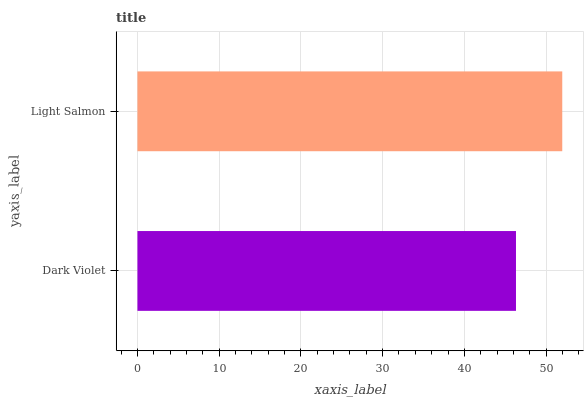Is Dark Violet the minimum?
Answer yes or no. Yes. Is Light Salmon the maximum?
Answer yes or no. Yes. Is Light Salmon the minimum?
Answer yes or no. No. Is Light Salmon greater than Dark Violet?
Answer yes or no. Yes. Is Dark Violet less than Light Salmon?
Answer yes or no. Yes. Is Dark Violet greater than Light Salmon?
Answer yes or no. No. Is Light Salmon less than Dark Violet?
Answer yes or no. No. Is Light Salmon the high median?
Answer yes or no. Yes. Is Dark Violet the low median?
Answer yes or no. Yes. Is Dark Violet the high median?
Answer yes or no. No. Is Light Salmon the low median?
Answer yes or no. No. 